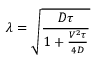<formula> <loc_0><loc_0><loc_500><loc_500>\lambda = \sqrt { \frac { D \tau } { 1 + \frac { V ^ { 2 } \tau } { 4 D } } }</formula> 